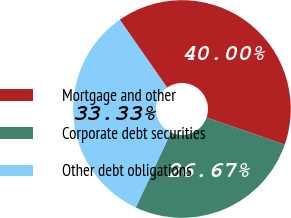<chart> <loc_0><loc_0><loc_500><loc_500><pie_chart><fcel>Mortgage and other<fcel>Corporate debt securities<fcel>Other debt obligations<nl><fcel>40.0%<fcel>26.67%<fcel>33.33%<nl></chart> 